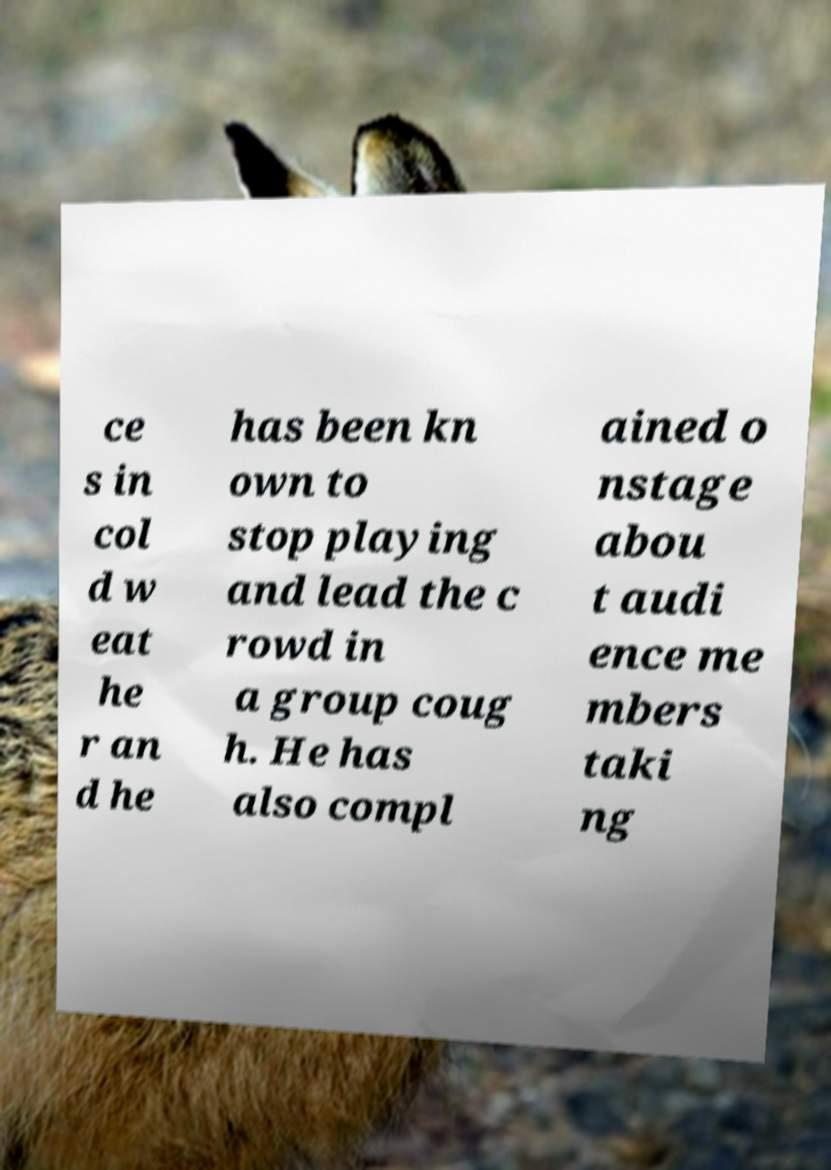Can you accurately transcribe the text from the provided image for me? ce s in col d w eat he r an d he has been kn own to stop playing and lead the c rowd in a group coug h. He has also compl ained o nstage abou t audi ence me mbers taki ng 